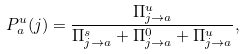Convert formula to latex. <formula><loc_0><loc_0><loc_500><loc_500>P _ { a } ^ { u } ( j ) = \frac { \Pi _ { j \rightarrow a } ^ { u } } { \Pi _ { j \rightarrow a } ^ { s } + \Pi _ { j \rightarrow a } ^ { 0 } + \Pi _ { j \rightarrow a } ^ { u } } ,</formula> 